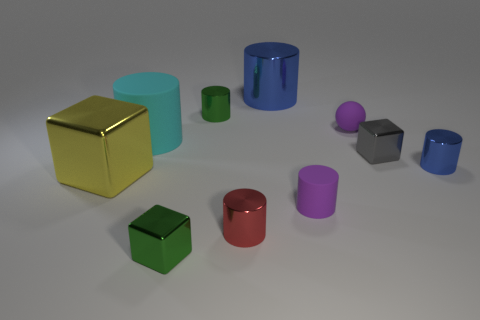Does the tiny matte sphere have the same color as the small matte cylinder?
Provide a short and direct response. Yes. The blue object that is on the left side of the rubber thing that is right of the purple matte thing in front of the cyan matte object is what shape?
Provide a short and direct response. Cylinder. What number of objects are either metallic cylinders that are behind the small sphere or green metallic objects in front of the green metallic cylinder?
Your answer should be compact. 3. What is the size of the rubber thing that is to the left of the large object that is to the right of the small green cylinder?
Provide a short and direct response. Large. There is a tiny matte object that is to the right of the tiny matte cylinder; does it have the same color as the tiny matte cylinder?
Your response must be concise. Yes. Are there any small green things of the same shape as the gray shiny object?
Offer a terse response. Yes. What color is the metallic cube that is the same size as the cyan object?
Your answer should be compact. Yellow. What size is the cyan rubber cylinder in front of the big blue cylinder?
Your response must be concise. Large. There is a matte object that is in front of the big rubber cylinder; are there any small red metal cylinders that are on the right side of it?
Provide a short and direct response. No. Are the blue thing behind the tiny blue shiny cylinder and the tiny purple cylinder made of the same material?
Give a very brief answer. No. 